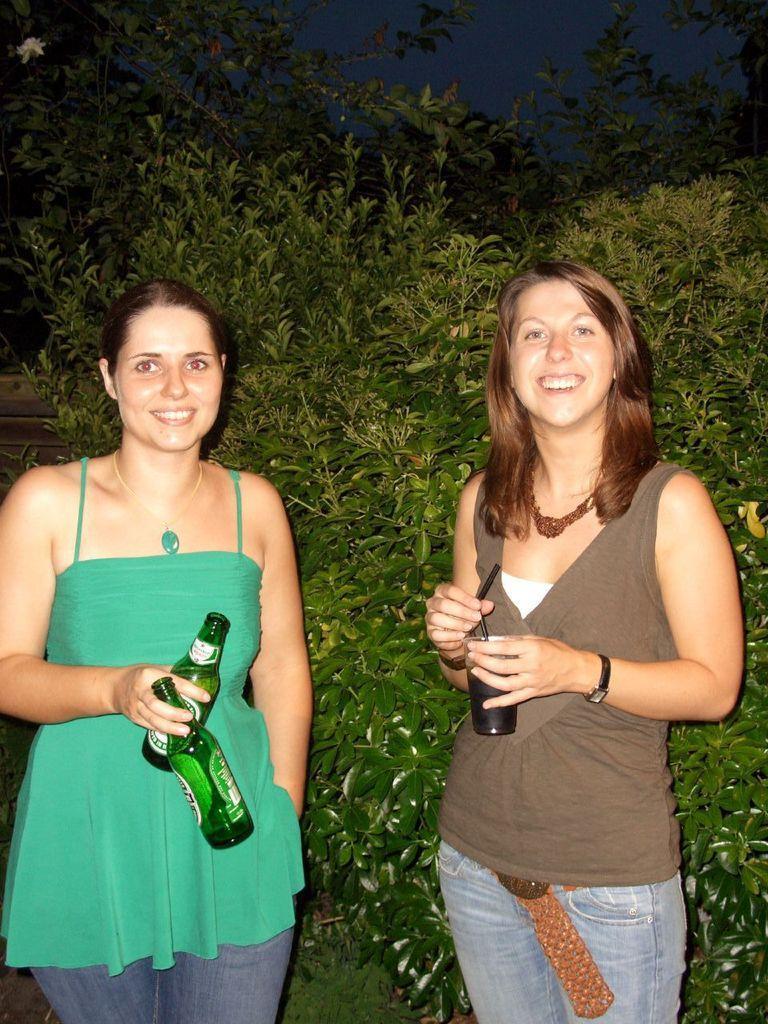In one or two sentences, can you explain what this image depicts? On the right there is a woman who is wearing grey t-shirt, jeans and holding wine glass. On the left there is another woman who is wearing green dress and holding wine bottles. Both of them were standing near to the plants. At the top we can see sky and stars. 